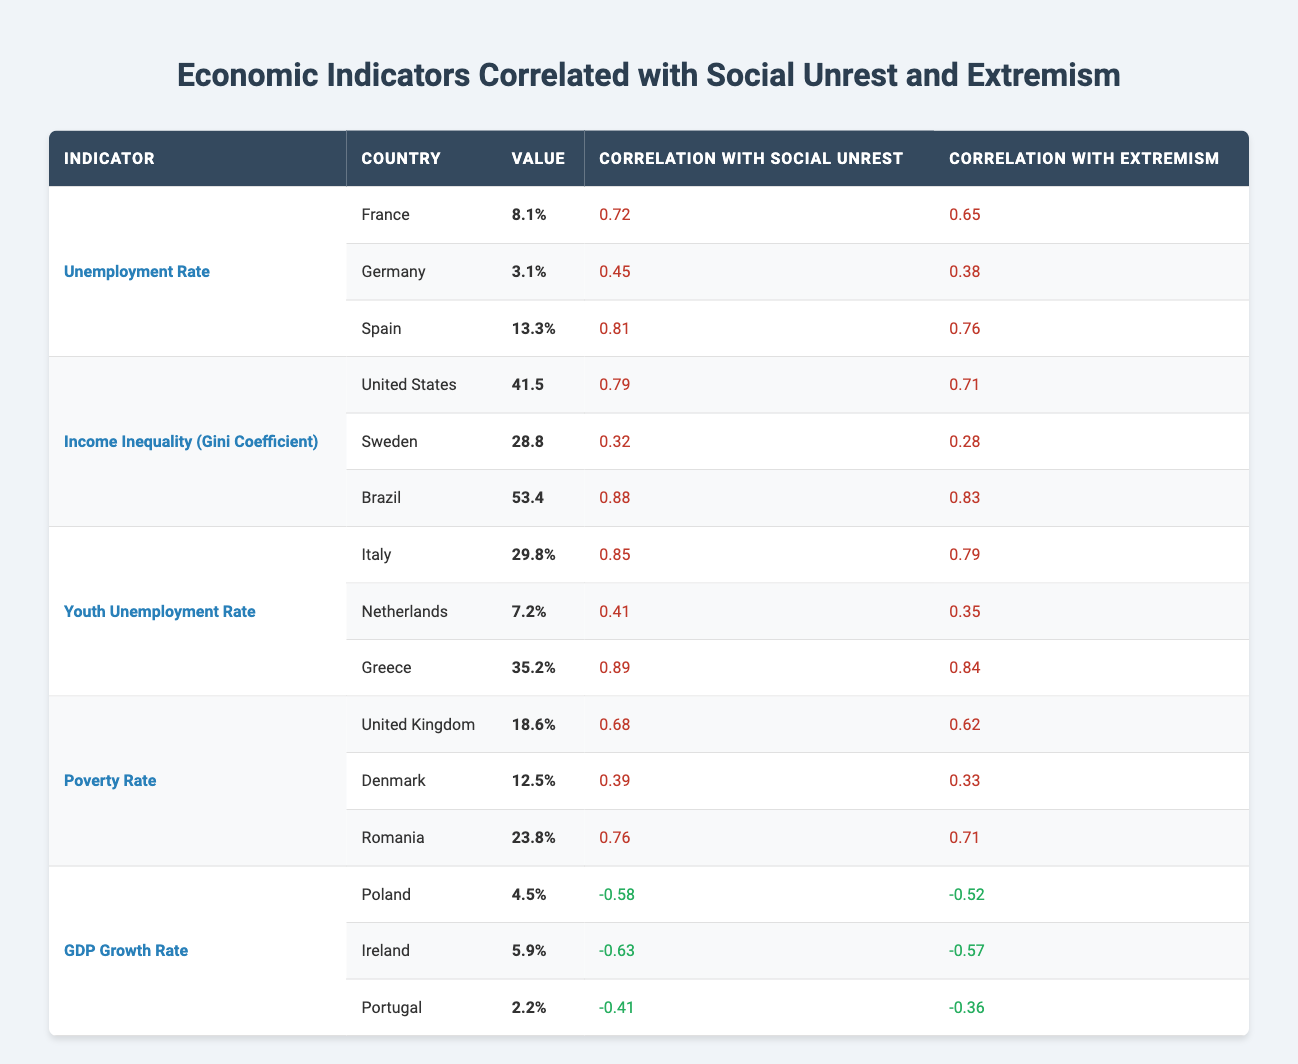What is the unemployment rate in Spain? The unemployment rate for Spain is directly listed in the table under the "Unemployment Rate" section for Spain, which shows a value of 13.3%.
Answer: 13.3% Which country has the highest correlation between its income inequality and social unrest? The correlation values for social unrest against income inequality are provided for each country. Brazil has the highest correlation of 0.88, indicating a strong relationship.
Answer: Brazil What is the average youth unemployment rate of Italy and Greece? The youth unemployment rates for Italy (29.8%) and Greece (35.2%) must first be summed: 29.8 + 35.2 = 65.0%. Then divide this sum by 2 to find the average: 65.0% / 2 = 32.5%.
Answer: 32.5% Is the correlation between GDP growth rate and extremism positive for any country in the table? The correlations with GDP growth rate for extremism are all negative values as shown in the table (-0.58 for Poland, -0.63 for Ireland, and -0.41 for Portugal), which means there is no positive correlation.
Answer: No Which country has a lower correlation with social unrest: United Kingdom or Denmark? The correlation values for social unrest are compared: the United Kingdom has a correlation of 0.68, while Denmark has 0.39. Since 0.39 is lower than 0.68, Denmark has the lower correlation.
Answer: Denmark What is the difference in the unemployment rate between France and Germany? To find the difference, subtract the unemployment rate of Germany (3.1%) from France's (8.1%): 8.1% - 3.1% = 5.0%.
Answer: 5.0% Which economic indicator shows the highest correlation with extremism in Brazil? The table lists Brazil's correlation with extremism under "Income Inequality (Gini Coefficient)", which is 0.83, the highest correlation listed for that country.
Answer: Income Inequality (Gini Coefficient) Does Sweden have a higher unemployment rate than Germany? The unemployment rate for Sweden is not provided in the unemployment rate section but by comparing the values provided in the table, Germany's rate (3.1%) is the only available rate for that indicator in that comparison group, indicating that Sweden is likely to have a higher rate.
Answer: Yes What is the poverty rate in Romania, and how does it correlate with social unrest? The table shows that Romania's poverty rate is 23.8% with a correlation to social unrest of 0.76. Both pieces of information are stated together in the same section of the table under Poverty Rate.
Answer: 23.8%, 0.76 